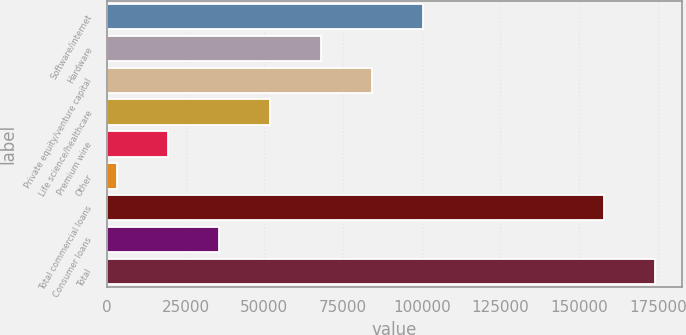Convert chart. <chart><loc_0><loc_0><loc_500><loc_500><bar_chart><fcel>Software/internet<fcel>Hardware<fcel>Private equity/venture capital<fcel>Life science/healthcare<fcel>Premium wine<fcel>Other<fcel>Total commercial loans<fcel>Consumer loans<fcel>Total<nl><fcel>100517<fcel>68095.4<fcel>84306<fcel>51884.8<fcel>19463.6<fcel>3253<fcel>157772<fcel>35674.2<fcel>173983<nl></chart> 